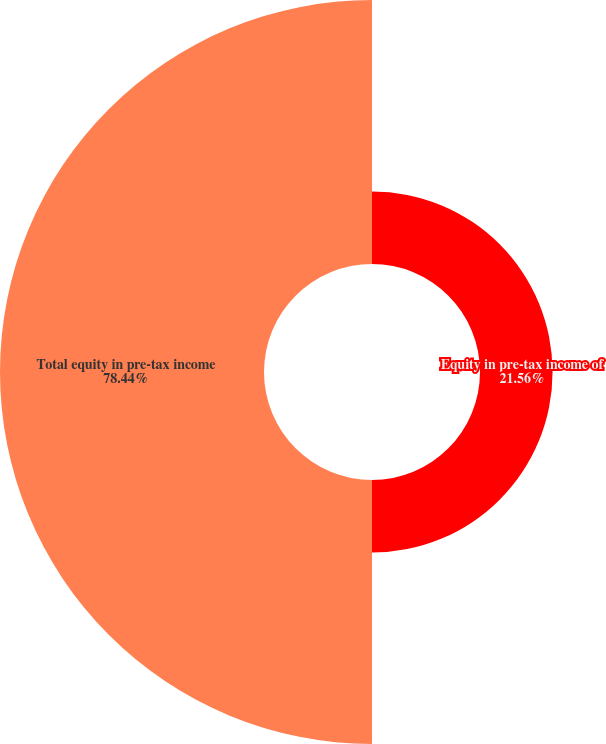<chart> <loc_0><loc_0><loc_500><loc_500><pie_chart><fcel>Equity in pre-tax income of<fcel>Total equity in pre-tax income<nl><fcel>21.56%<fcel>78.44%<nl></chart> 